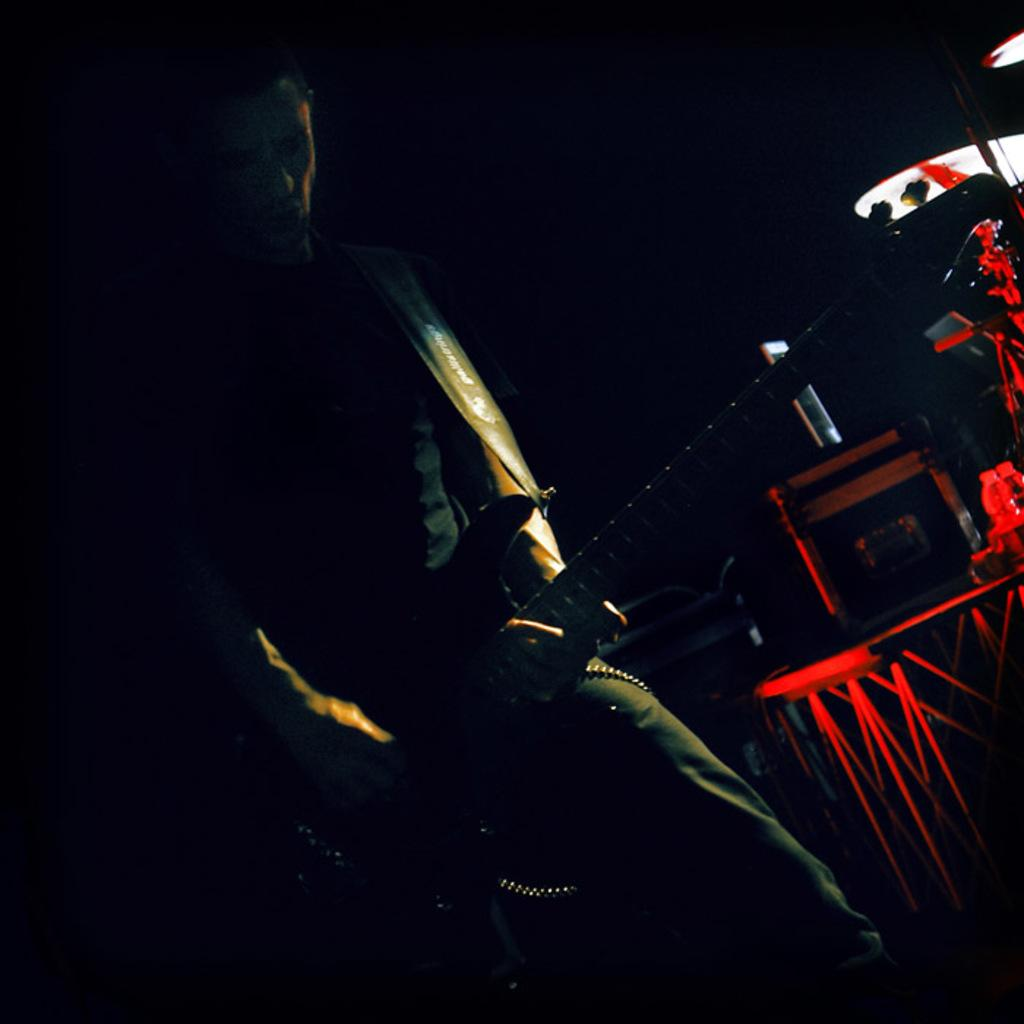Who is the main subject in the image? There is a man standing in the center of the image. What is the man holding in the image? The man is holding a guitar. What else can be seen on the right side of the image? There is a band and a speaker on the right side of the image. How many legs does the feather have in the image? There is no feather present in the image. What type of collar is the man wearing in the image? The man is not wearing a collar in the image. 